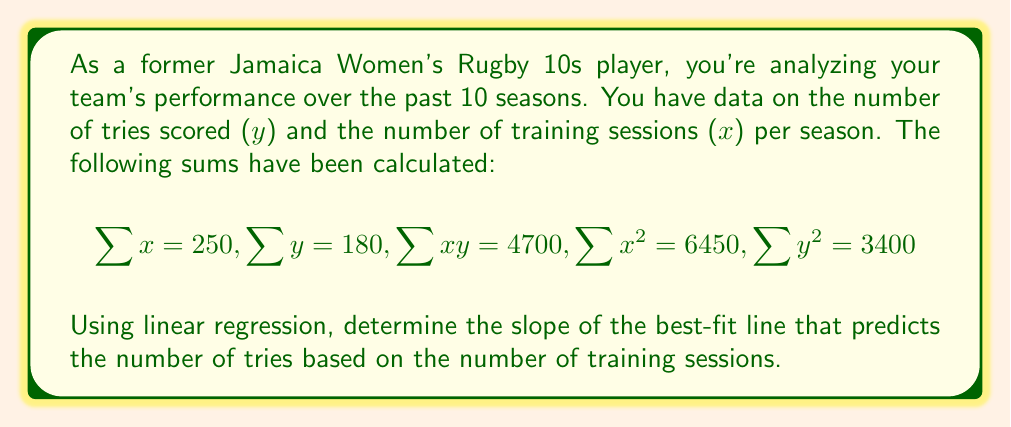Can you answer this question? To find the slope of the best-fit line using linear regression, we'll use the formula:

$$m = \frac{n\sum xy - \sum x \sum y}{n\sum x^2 - (\sum x)^2}$$

Where:
- $n$ is the number of data points (seasons)
- $m$ is the slope of the best-fit line

Step 1: Determine $n$
Since we have 10 seasons of data, $n = 10$

Step 2: Substitute the given values into the formula
$$m = \frac{10(4700) - (250)(180)}{10(6450) - (250)^2}$$

Step 3: Simplify the numerator
$$m = \frac{47000 - 45000}{10(6450) - (250)^2}$$
$$m = \frac{2000}{10(6450) - (250)^2}$$

Step 4: Simplify the denominator
$$m = \frac{2000}{64500 - 62500}$$
$$m = \frac{2000}{2000}$$

Step 5: Calculate the final result
$$m = 1$$
Answer: $1$ 